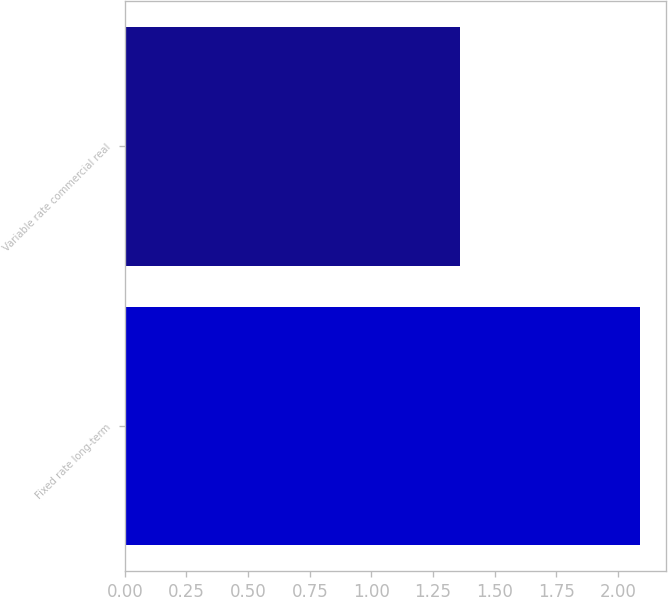Convert chart. <chart><loc_0><loc_0><loc_500><loc_500><bar_chart><fcel>Fixed rate long-term<fcel>Variable rate commercial real<nl><fcel>2.09<fcel>1.36<nl></chart> 